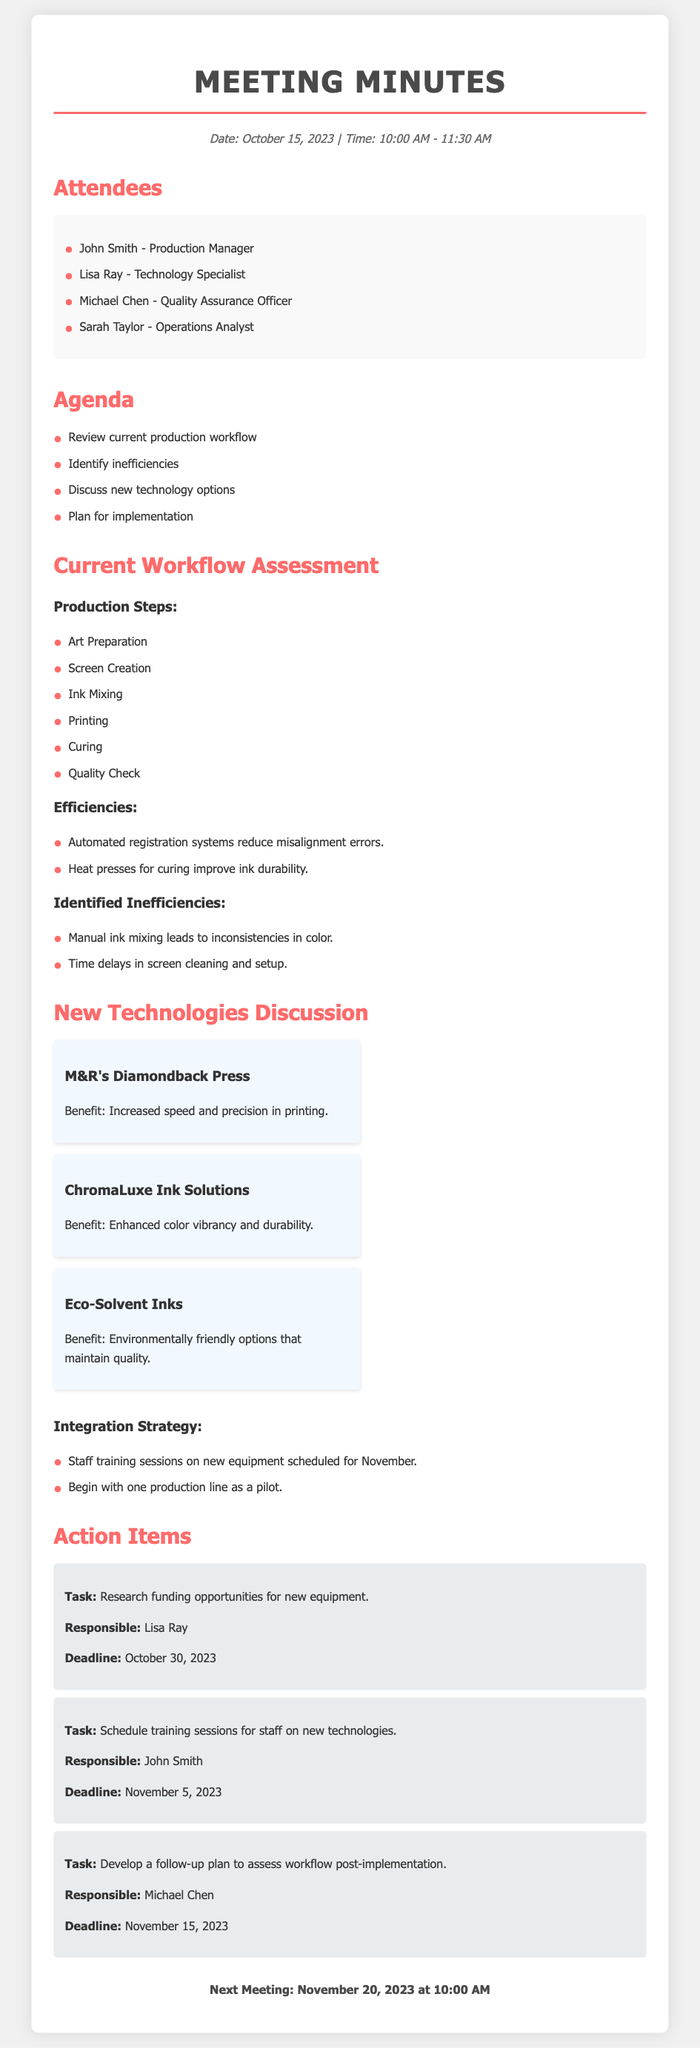what is the date of the meeting? The date of the meeting is listed at the top of the document.
Answer: October 15, 2023 who is responsible for researching funding opportunities? The document specifies responsibilities assigned to attendees.
Answer: Lisa Ray what is one identified inefficiency in the current workflow? The document lists inefficiencies found during the workflow assessment.
Answer: Manual ink mixing leads to inconsistencies in color what is the benefit of using M&R's Diamondback Press? The document states the advantages of discussing new technologies.
Answer: Increased speed and precision in printing when is the next meeting scheduled? The next meeting date is mentioned at the bottom of the document.
Answer: November 20, 2023 which technology option enhances color vibrancy and durability? The document discusses technological solutions and their benefits.
Answer: ChromaLuxe Ink Solutions how many action items are listed in the document? The document enumerates tasks to be completed after the meeting.
Answer: Three 